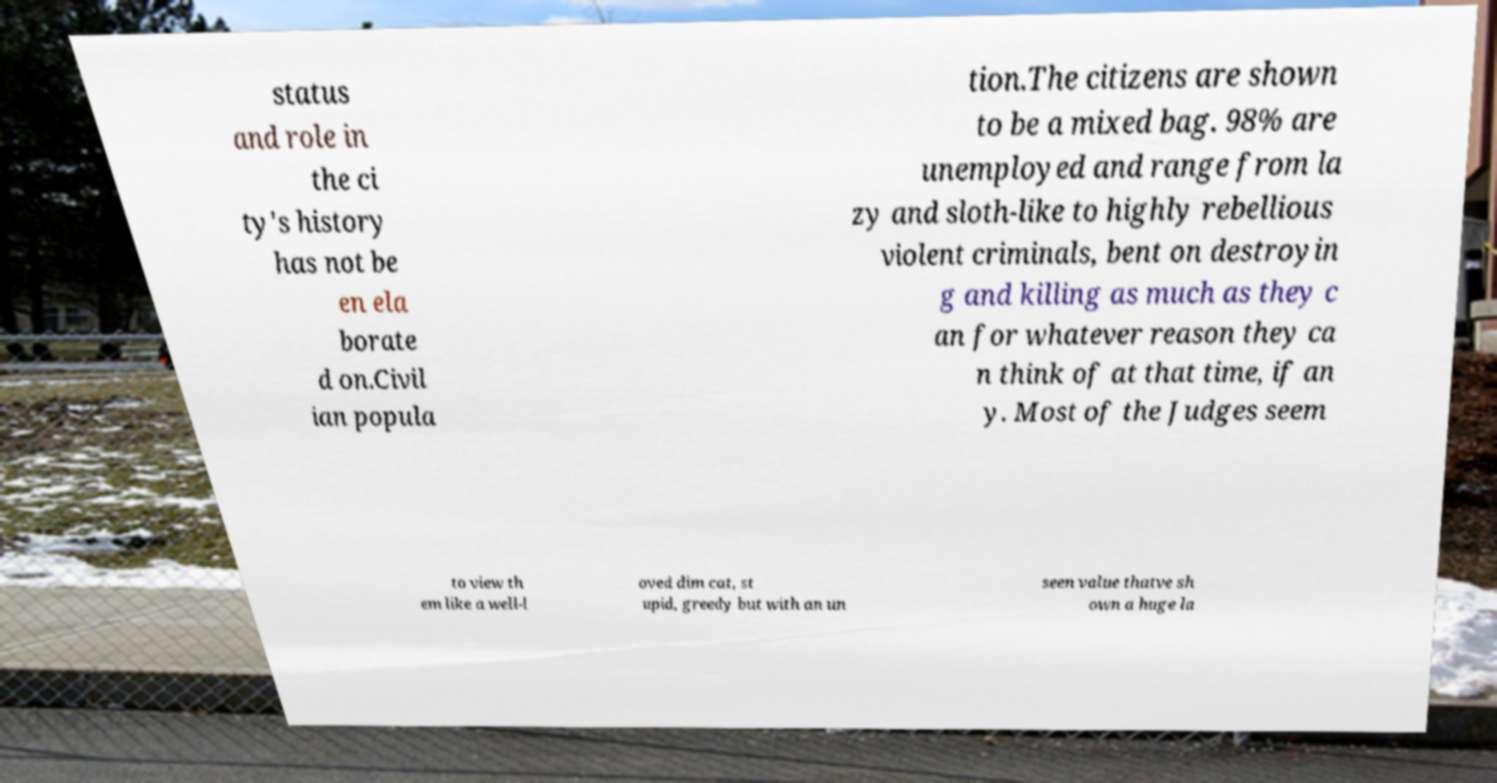Could you assist in decoding the text presented in this image and type it out clearly? status and role in the ci ty's history has not be en ela borate d on.Civil ian popula tion.The citizens are shown to be a mixed bag. 98% are unemployed and range from la zy and sloth-like to highly rebellious violent criminals, bent on destroyin g and killing as much as they c an for whatever reason they ca n think of at that time, if an y. Most of the Judges seem to view th em like a well-l oved dim cat, st upid, greedy but with an un seen value thatve sh own a huge la 